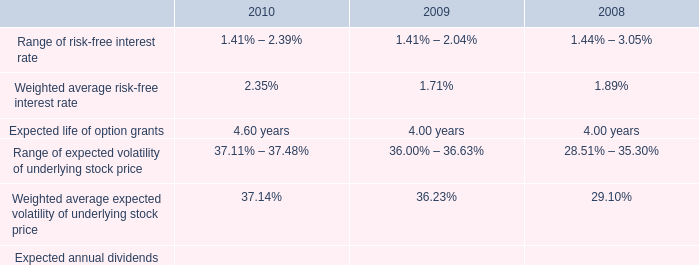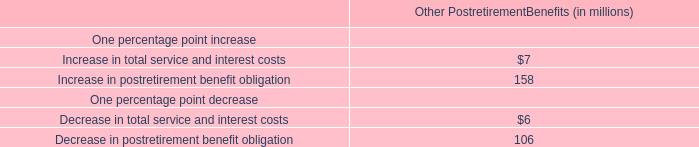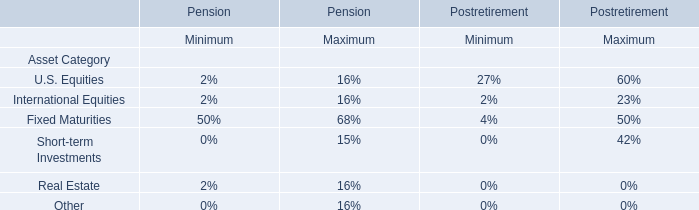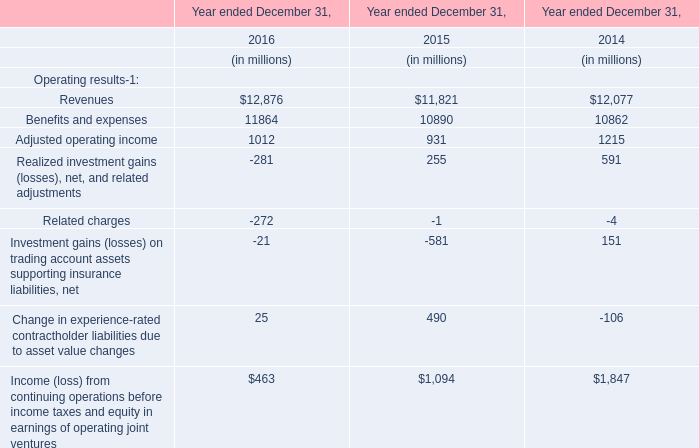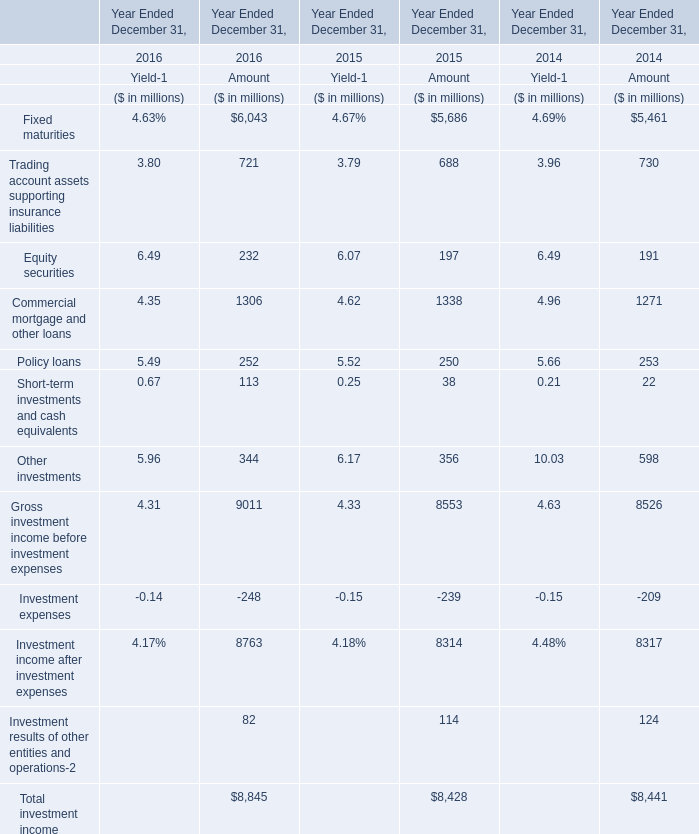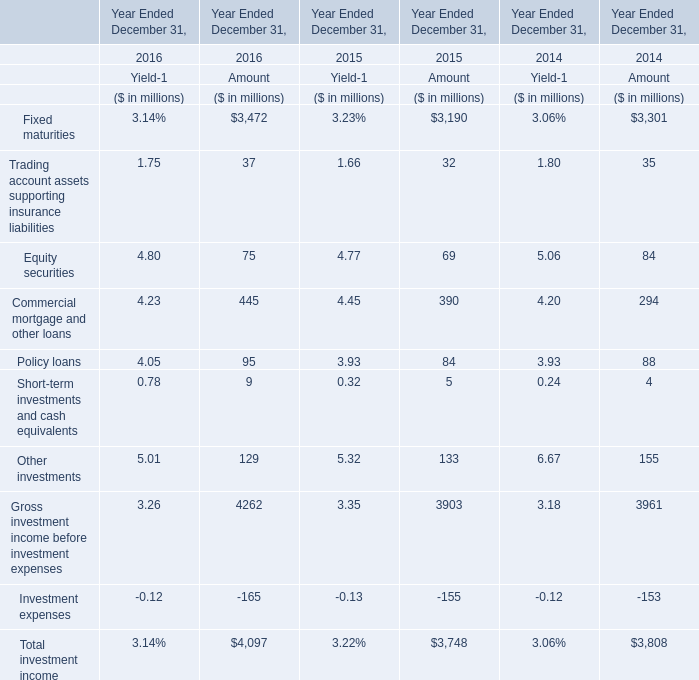what was the percent of the change in the intrinsic value of stock options from 2009 to 2010 
Computations: ((62.7 - 40.1) / 40.1)
Answer: 0.56359. 